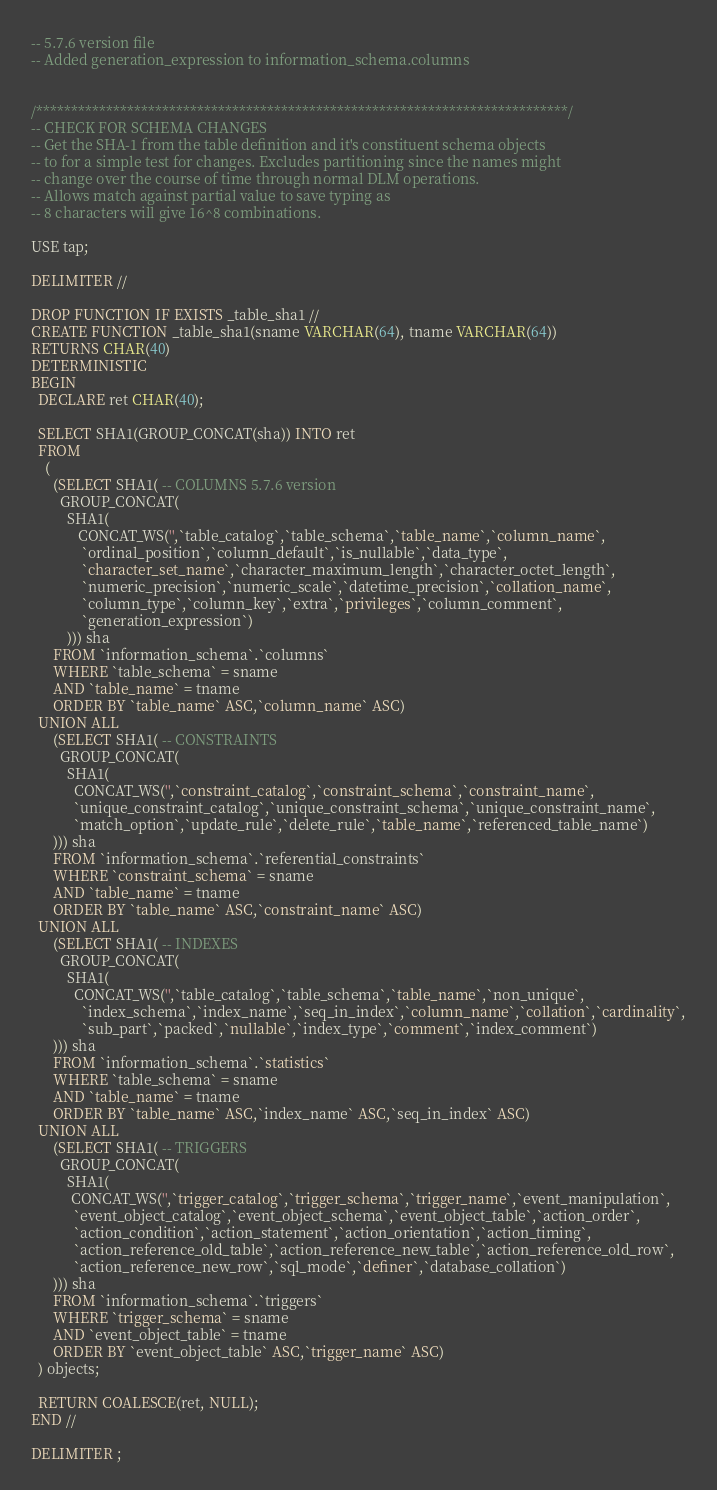<code> <loc_0><loc_0><loc_500><loc_500><_SQL_>-- 5.7.6 version file
-- Added generation_expression to information_schema.columns


/****************************************************************************/
-- CHECK FOR SCHEMA CHANGES
-- Get the SHA-1 from the table definition and it's constituent schema objects 
-- to for a simple test for changes. Excludes partitioning since the names might
-- change over the course of time through normal DLM operations.
-- Allows match against partial value to save typing as
-- 8 characters will give 16^8 combinations.

USE tap;

DELIMITER //

DROP FUNCTION IF EXISTS _table_sha1 //
CREATE FUNCTION _table_sha1(sname VARCHAR(64), tname VARCHAR(64))
RETURNS CHAR(40)
DETERMINISTIC
BEGIN
  DECLARE ret CHAR(40);

  SELECT SHA1(GROUP_CONCAT(sha)) INTO ret
  FROM 
    (   
      (SELECT SHA1( -- COLUMNS 5.7.6 version
        GROUP_CONCAT(
          SHA1(
             CONCAT_WS('',`table_catalog`,`table_schema`,`table_name`,`column_name`,
              `ordinal_position`,`column_default`,`is_nullable`,`data_type`,
              `character_set_name`,`character_maximum_length`,`character_octet_length`,
              `numeric_precision`,`numeric_scale`,`datetime_precision`,`collation_name`,
              `column_type`,`column_key`,`extra`,`privileges`,`column_comment`,
              `generation_expression`)
          ))) sha
      FROM `information_schema`.`columns`
      WHERE `table_schema` = sname
      AND `table_name` = tname
      ORDER BY `table_name` ASC,`column_name` ASC)
  UNION ALL
      (SELECT SHA1( -- CONSTRAINTS
        GROUP_CONCAT(
          SHA1(
            CONCAT_WS('',`constraint_catalog`,`constraint_schema`,`constraint_name`,
            `unique_constraint_catalog`,`unique_constraint_schema`,`unique_constraint_name`,
            `match_option`,`update_rule`,`delete_rule`,`table_name`,`referenced_table_name`)
      ))) sha
      FROM `information_schema`.`referential_constraints`
      WHERE `constraint_schema` = sname
      AND `table_name` = tname
      ORDER BY `table_name` ASC,`constraint_name` ASC)
  UNION ALL
      (SELECT SHA1( -- INDEXES
        GROUP_CONCAT(
          SHA1(
            CONCAT_WS('',`table_catalog`,`table_schema`,`table_name`,`non_unique`,
              `index_schema`,`index_name`,`seq_in_index`,`column_name`,`collation`,`cardinality`,
              `sub_part`,`packed`,`nullable`,`index_type`,`comment`,`index_comment`)
      ))) sha
      FROM `information_schema`.`statistics`
      WHERE `table_schema` = sname
      AND `table_name` = tname
      ORDER BY `table_name` ASC,`index_name` ASC,`seq_in_index` ASC)
  UNION ALL
      (SELECT SHA1( -- TRIGGERS
        GROUP_CONCAT(
          SHA1(
           CONCAT_WS('',`trigger_catalog`,`trigger_schema`,`trigger_name`,`event_manipulation`,
            `event_object_catalog`,`event_object_schema`,`event_object_table`,`action_order`,
            `action_condition`,`action_statement`,`action_orientation`,`action_timing`,
            `action_reference_old_table`,`action_reference_new_table`,`action_reference_old_row`,
            `action_reference_new_row`,`sql_mode`,`definer`,`database_collation`)
      ))) sha
      FROM `information_schema`.`triggers`
      WHERE `trigger_schema` = sname
      AND `event_object_table` = tname
      ORDER BY `event_object_table` ASC,`trigger_name` ASC)
  ) objects;

  RETURN COALESCE(ret, NULL);
END //

DELIMITER ;
</code> 